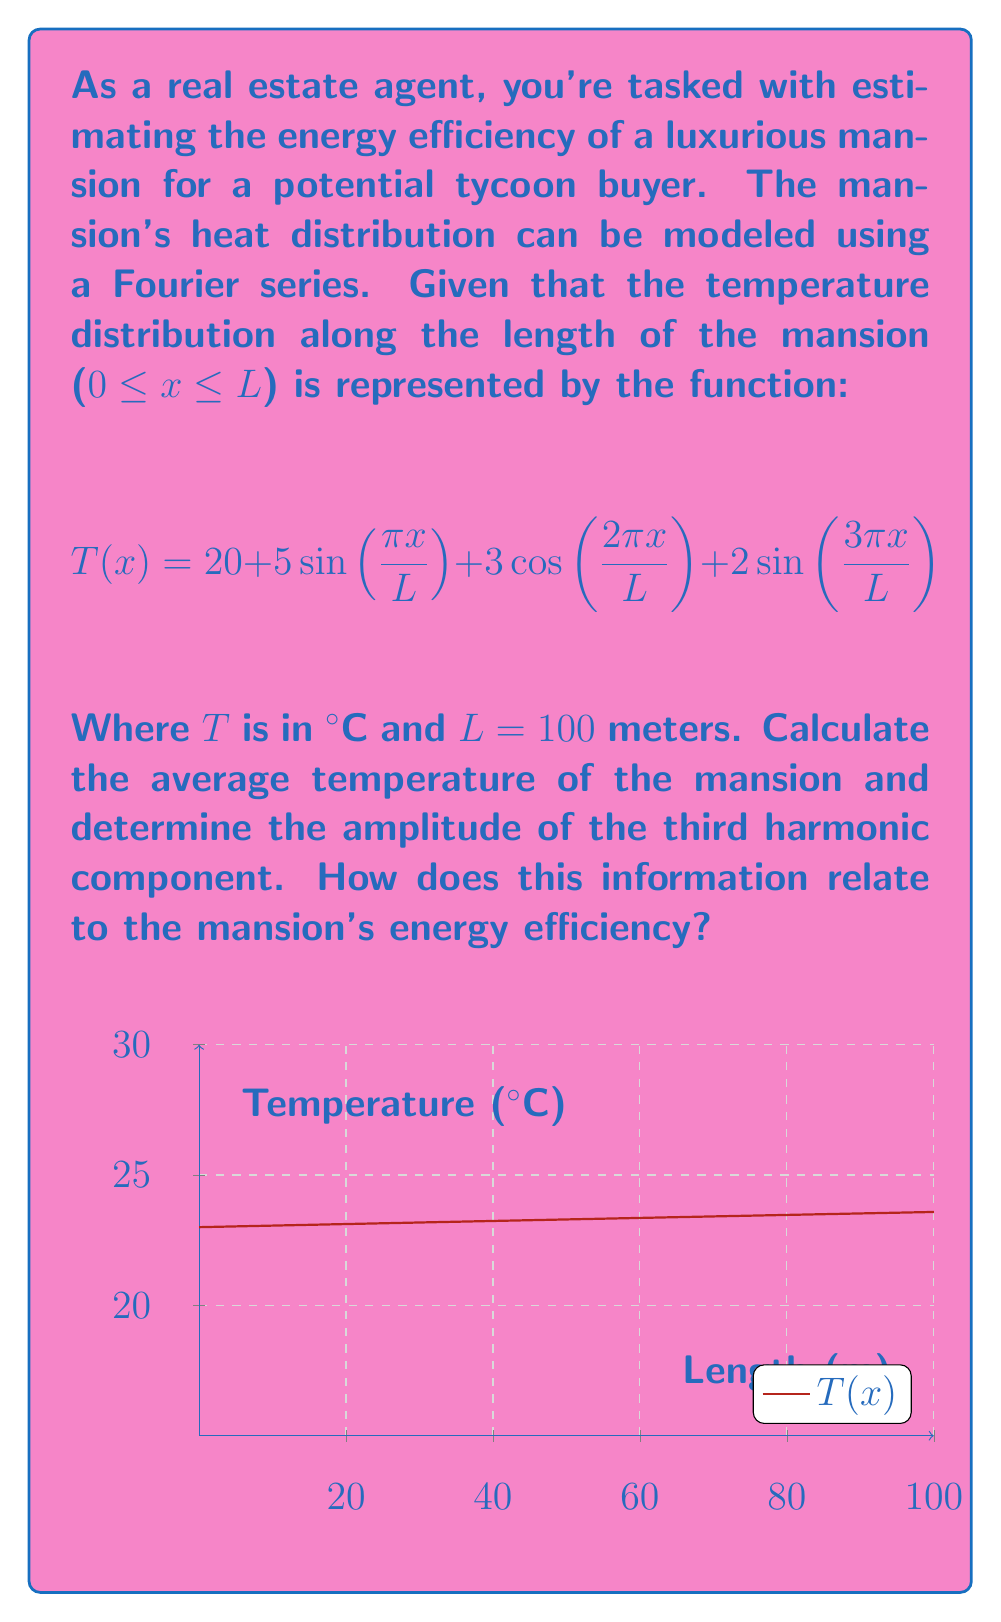Show me your answer to this math problem. To solve this problem, we'll follow these steps:

1) The average temperature is given by the constant term in the Fourier series. In this case, it's 20°C.

2) The third harmonic component is the term with $\frac{3\pi x}{L}$ in its argument. Here, it's $2\sin(\frac{3\pi x}{L})$. The amplitude of this component is 2°C.

3) To relate this to energy efficiency:

   a) The average temperature (20°C) gives us a baseline for the mansion's overall heat. A lower average temperature generally indicates better energy efficiency.

   b) The amplitude of the harmonics (including the third harmonic with 2°C amplitude) indicates temperature fluctuations. Smaller amplitudes suggest more uniform heating, which is typically more energy-efficient.

   c) The presence of higher harmonics (like the third) indicates more complex temperature distributions, which might suggest areas of heat loss or inefficient heating.

In this case, the relatively low amplitudes of the harmonic components (5°C, 3°C, and 2°C) compared to the average temperature (20°C) suggest that the temperature distribution is fairly uniform, which is a positive indicator for energy efficiency. However, the presence of these harmonics also indicates some temperature variations that could be addressed to further improve efficiency.
Answer: Average temperature: 20°C; Third harmonic amplitude: 2°C; Interpretation: Fairly uniform heating with some variations, indicating moderate to good energy efficiency. 